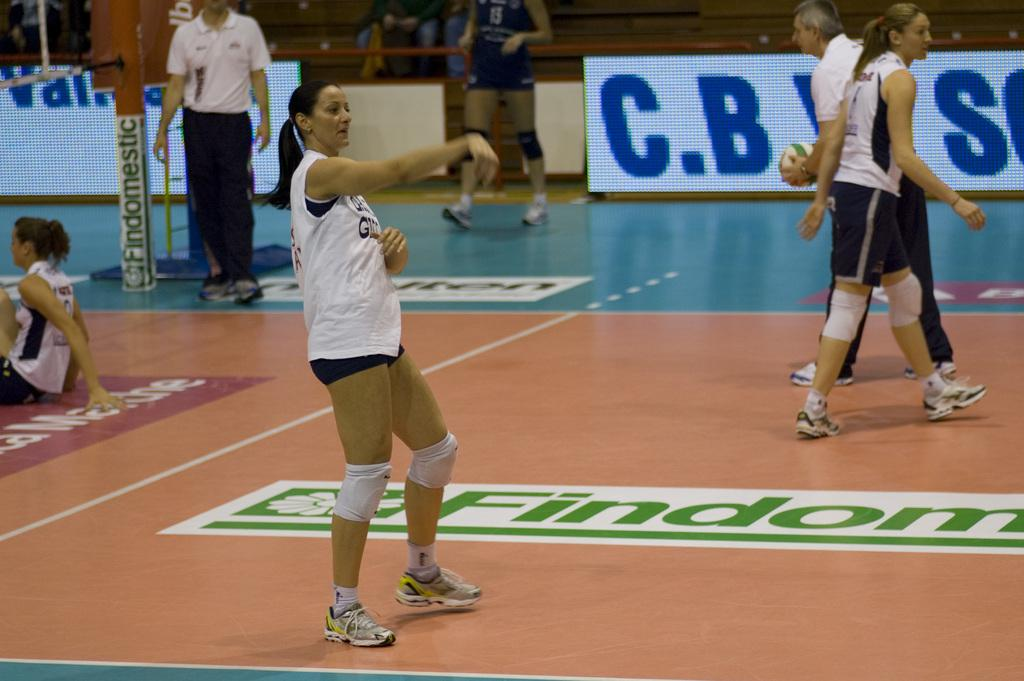What is the setting of the image? The setting of the image is inside a stadium. What are the people in the image doing? The people are standing on the floor inside the stadium. What can be seen on the stadium floor? There is text visible on the stadium floor. What other objects are present in the stadium? There are poles and boards in the stadium. What is the seating arrangement in the stadium? There are other people sitting in the stadium. What type of fruit is being served to the people sitting in the stadium? There is no fruit visible in the image, and no indication that any food is being served. How many servants are attending to the people in the stadium? There is no mention of servants in the image, as the focus is on the people standing and sitting in the stadium. 